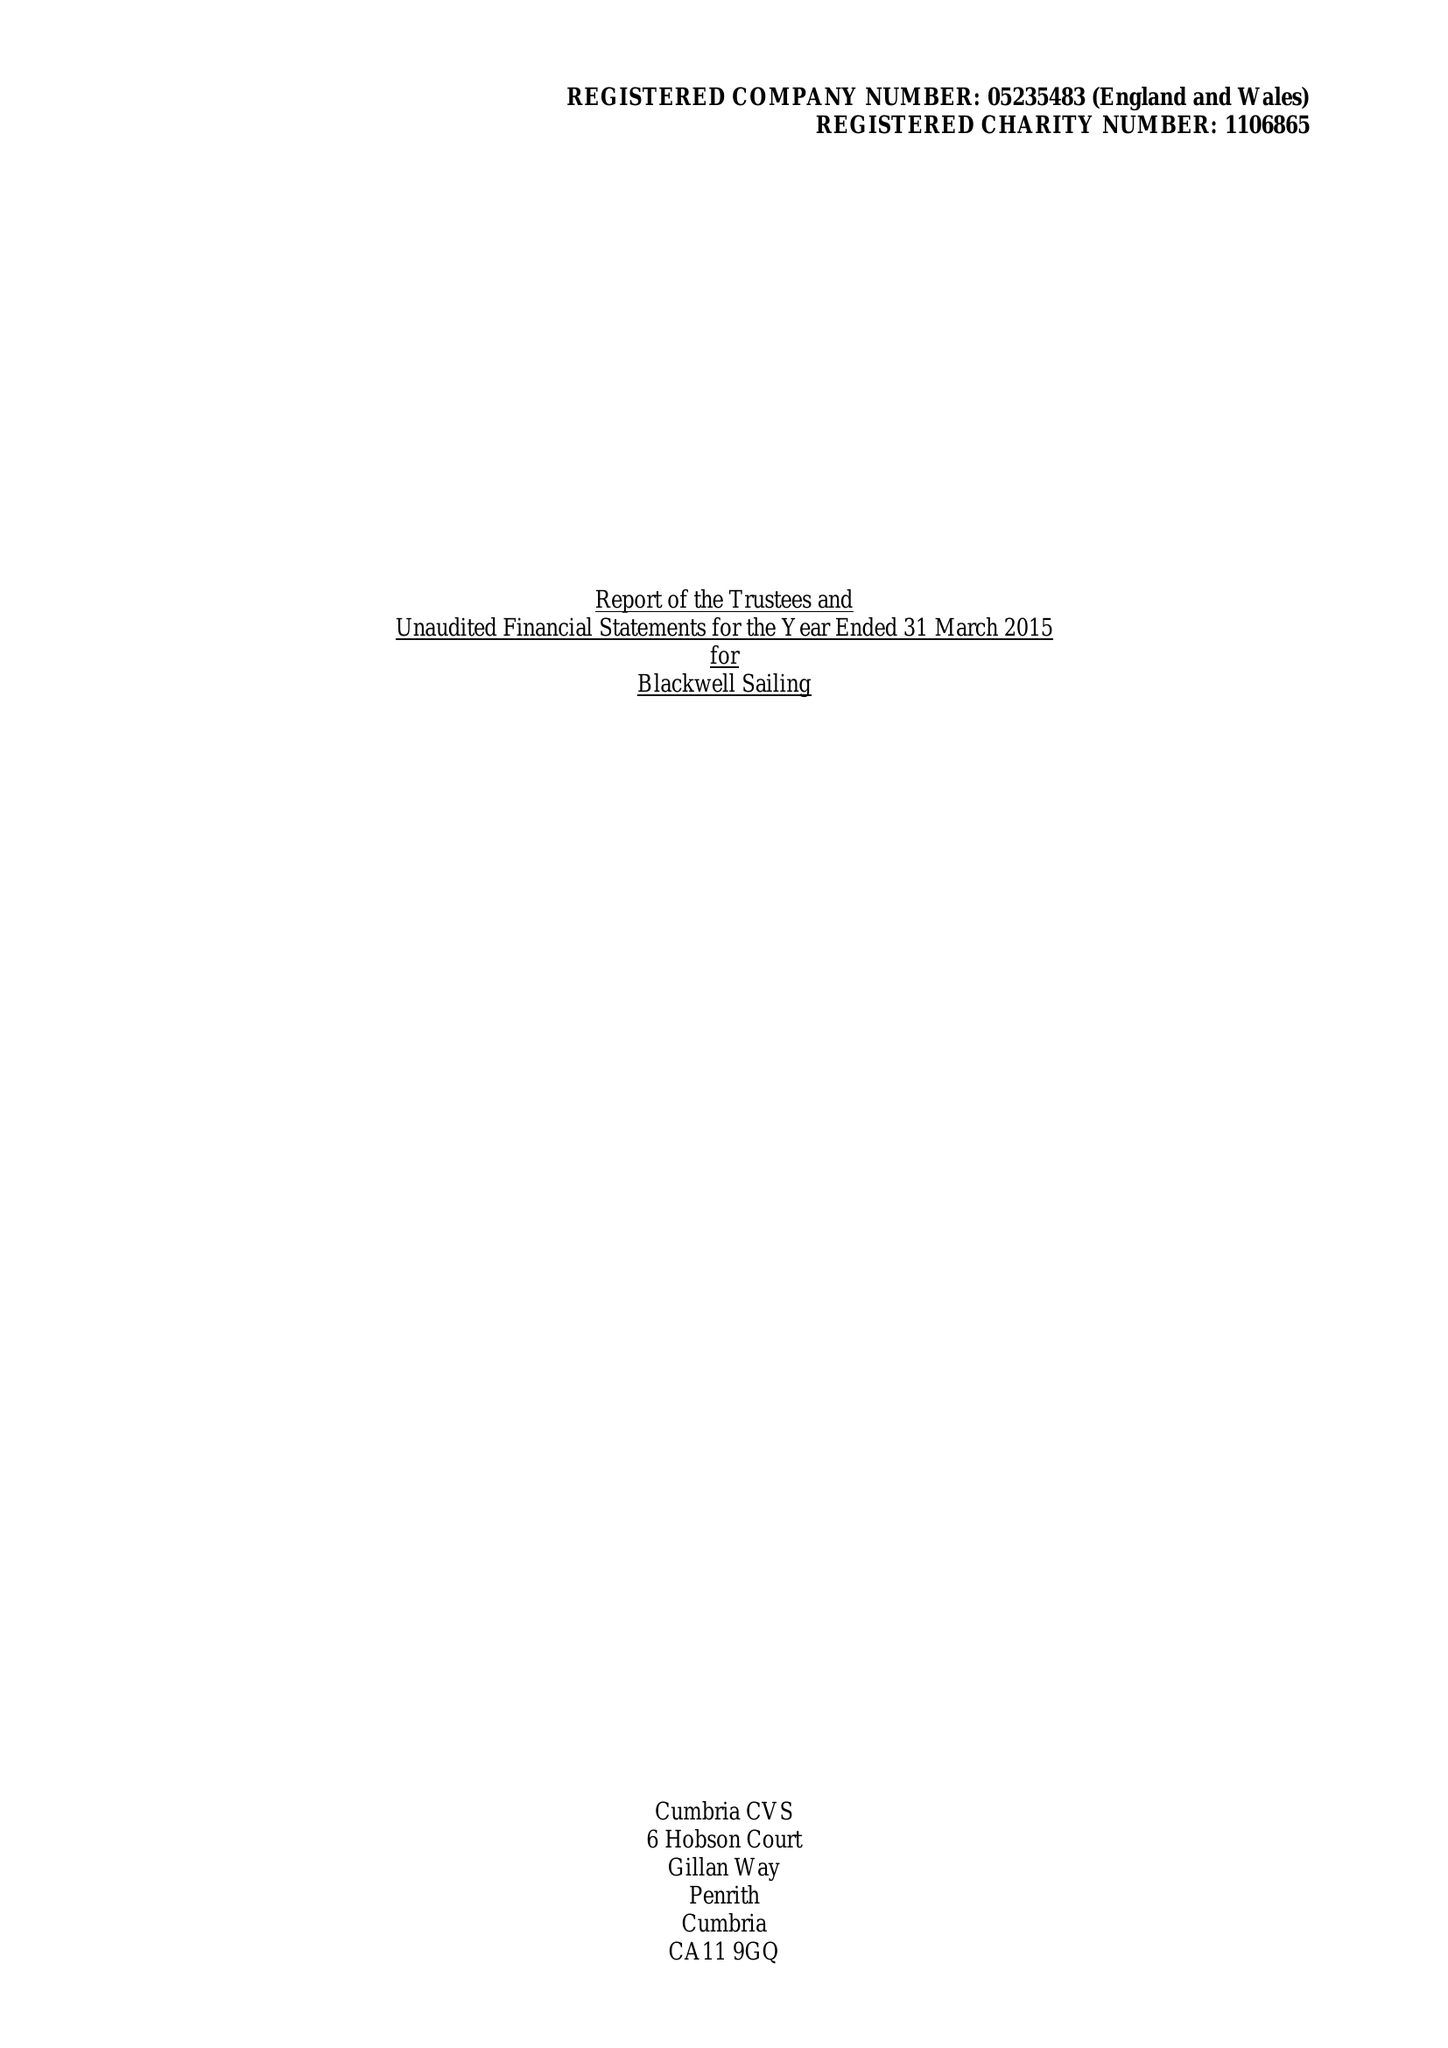What is the value for the address__street_line?
Answer the question using a single word or phrase. GLEBE ROAD 